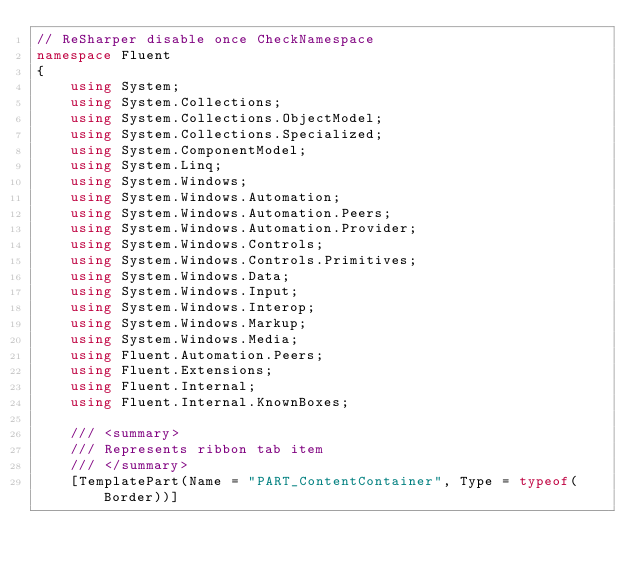<code> <loc_0><loc_0><loc_500><loc_500><_C#_>// ReSharper disable once CheckNamespace
namespace Fluent
{
    using System;
    using System.Collections;
    using System.Collections.ObjectModel;
    using System.Collections.Specialized;
    using System.ComponentModel;
    using System.Linq;
    using System.Windows;
    using System.Windows.Automation;
    using System.Windows.Automation.Peers;
    using System.Windows.Automation.Provider;
    using System.Windows.Controls;
    using System.Windows.Controls.Primitives;
    using System.Windows.Data;
    using System.Windows.Input;
    using System.Windows.Interop;
    using System.Windows.Markup;
    using System.Windows.Media;
    using Fluent.Automation.Peers;
    using Fluent.Extensions;
    using Fluent.Internal;
    using Fluent.Internal.KnownBoxes;

    /// <summary>
    /// Represents ribbon tab item
    /// </summary>
    [TemplatePart(Name = "PART_ContentContainer", Type = typeof(Border))]</code> 